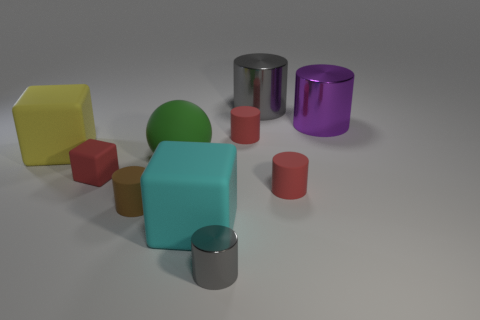Are there any red rubber blocks behind the large green ball? After examining the image, there aren't any red blocks situated behind the large green ball. In fact, there is only a green cylinder directly behind the green ball, and all the red blocks in view are positioned elsewhere. 